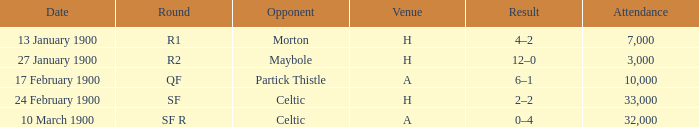How many individuals were present during the match against morton? 7000.0. 